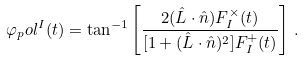Convert formula to latex. <formula><loc_0><loc_0><loc_500><loc_500>\varphi _ { p } o l ^ { I } ( t ) = \tan ^ { - 1 } \left [ \frac { 2 ( \hat { L } \cdot \hat { n } ) F _ { I } ^ { \times } ( t ) } { [ 1 + ( \hat { L } \cdot \hat { n } ) ^ { 2 } ] F _ { I } ^ { + } ( t ) } \right ] \, .</formula> 